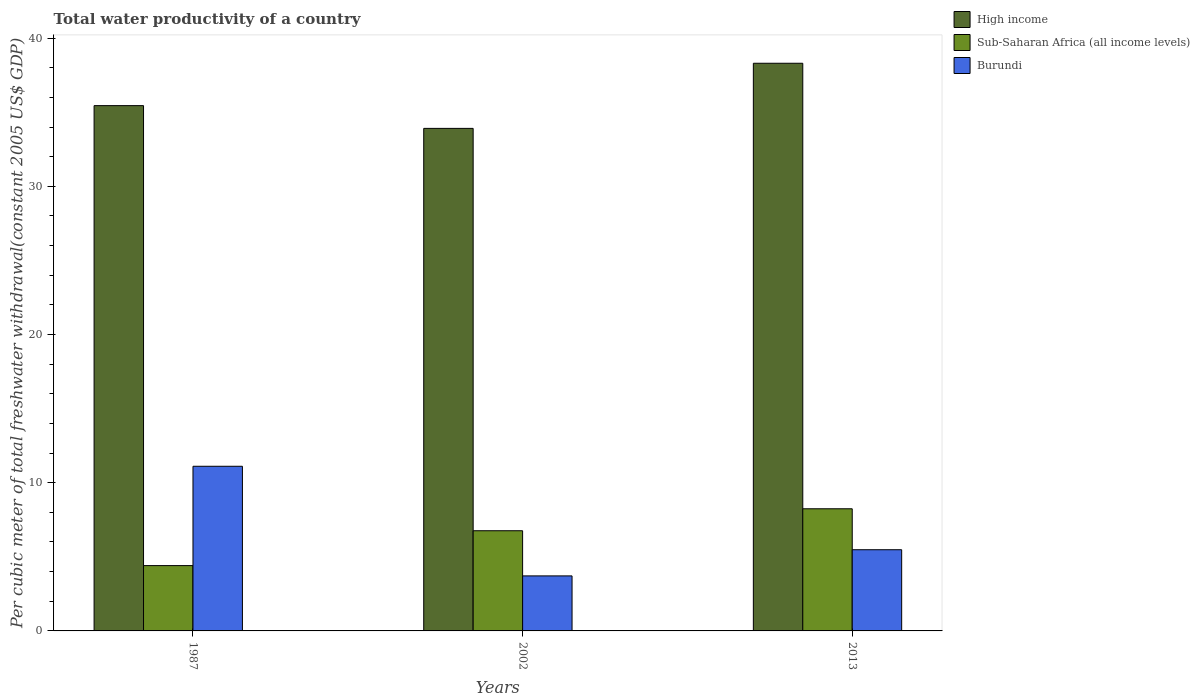How many different coloured bars are there?
Your answer should be very brief. 3. Are the number of bars on each tick of the X-axis equal?
Keep it short and to the point. Yes. How many bars are there on the 1st tick from the right?
Keep it short and to the point. 3. In how many cases, is the number of bars for a given year not equal to the number of legend labels?
Provide a short and direct response. 0. What is the total water productivity in Burundi in 2002?
Offer a very short reply. 3.71. Across all years, what is the maximum total water productivity in High income?
Give a very brief answer. 38.3. Across all years, what is the minimum total water productivity in Burundi?
Provide a succinct answer. 3.71. In which year was the total water productivity in High income maximum?
Make the answer very short. 2013. In which year was the total water productivity in Burundi minimum?
Your response must be concise. 2002. What is the total total water productivity in High income in the graph?
Give a very brief answer. 107.66. What is the difference between the total water productivity in High income in 2002 and that in 2013?
Ensure brevity in your answer.  -4.39. What is the difference between the total water productivity in High income in 2002 and the total water productivity in Burundi in 2013?
Provide a short and direct response. 28.43. What is the average total water productivity in Sub-Saharan Africa (all income levels) per year?
Your answer should be compact. 6.47. In the year 2013, what is the difference between the total water productivity in Burundi and total water productivity in High income?
Ensure brevity in your answer.  -32.82. What is the ratio of the total water productivity in Sub-Saharan Africa (all income levels) in 2002 to that in 2013?
Your answer should be compact. 0.82. Is the difference between the total water productivity in Burundi in 2002 and 2013 greater than the difference between the total water productivity in High income in 2002 and 2013?
Offer a very short reply. Yes. What is the difference between the highest and the second highest total water productivity in Burundi?
Provide a succinct answer. 5.63. What is the difference between the highest and the lowest total water productivity in Burundi?
Keep it short and to the point. 7.4. In how many years, is the total water productivity in Burundi greater than the average total water productivity in Burundi taken over all years?
Ensure brevity in your answer.  1. Is the sum of the total water productivity in Burundi in 1987 and 2002 greater than the maximum total water productivity in High income across all years?
Provide a short and direct response. No. What does the 3rd bar from the left in 2002 represents?
Offer a very short reply. Burundi. What does the 3rd bar from the right in 1987 represents?
Your response must be concise. High income. Is it the case that in every year, the sum of the total water productivity in High income and total water productivity in Sub-Saharan Africa (all income levels) is greater than the total water productivity in Burundi?
Provide a short and direct response. Yes. How many bars are there?
Your response must be concise. 9. What is the difference between two consecutive major ticks on the Y-axis?
Keep it short and to the point. 10. Are the values on the major ticks of Y-axis written in scientific E-notation?
Keep it short and to the point. No. How are the legend labels stacked?
Keep it short and to the point. Vertical. What is the title of the graph?
Offer a terse response. Total water productivity of a country. What is the label or title of the Y-axis?
Offer a terse response. Per cubic meter of total freshwater withdrawal(constant 2005 US$ GDP). What is the Per cubic meter of total freshwater withdrawal(constant 2005 US$ GDP) in High income in 1987?
Give a very brief answer. 35.44. What is the Per cubic meter of total freshwater withdrawal(constant 2005 US$ GDP) of Sub-Saharan Africa (all income levels) in 1987?
Provide a short and direct response. 4.41. What is the Per cubic meter of total freshwater withdrawal(constant 2005 US$ GDP) in Burundi in 1987?
Give a very brief answer. 11.11. What is the Per cubic meter of total freshwater withdrawal(constant 2005 US$ GDP) in High income in 2002?
Ensure brevity in your answer.  33.91. What is the Per cubic meter of total freshwater withdrawal(constant 2005 US$ GDP) in Sub-Saharan Africa (all income levels) in 2002?
Give a very brief answer. 6.76. What is the Per cubic meter of total freshwater withdrawal(constant 2005 US$ GDP) of Burundi in 2002?
Your response must be concise. 3.71. What is the Per cubic meter of total freshwater withdrawal(constant 2005 US$ GDP) of High income in 2013?
Offer a very short reply. 38.3. What is the Per cubic meter of total freshwater withdrawal(constant 2005 US$ GDP) in Sub-Saharan Africa (all income levels) in 2013?
Provide a succinct answer. 8.24. What is the Per cubic meter of total freshwater withdrawal(constant 2005 US$ GDP) of Burundi in 2013?
Provide a short and direct response. 5.48. Across all years, what is the maximum Per cubic meter of total freshwater withdrawal(constant 2005 US$ GDP) in High income?
Provide a succinct answer. 38.3. Across all years, what is the maximum Per cubic meter of total freshwater withdrawal(constant 2005 US$ GDP) of Sub-Saharan Africa (all income levels)?
Offer a very short reply. 8.24. Across all years, what is the maximum Per cubic meter of total freshwater withdrawal(constant 2005 US$ GDP) in Burundi?
Your answer should be compact. 11.11. Across all years, what is the minimum Per cubic meter of total freshwater withdrawal(constant 2005 US$ GDP) in High income?
Provide a succinct answer. 33.91. Across all years, what is the minimum Per cubic meter of total freshwater withdrawal(constant 2005 US$ GDP) of Sub-Saharan Africa (all income levels)?
Ensure brevity in your answer.  4.41. Across all years, what is the minimum Per cubic meter of total freshwater withdrawal(constant 2005 US$ GDP) of Burundi?
Your answer should be compact. 3.71. What is the total Per cubic meter of total freshwater withdrawal(constant 2005 US$ GDP) of High income in the graph?
Your answer should be very brief. 107.66. What is the total Per cubic meter of total freshwater withdrawal(constant 2005 US$ GDP) of Sub-Saharan Africa (all income levels) in the graph?
Offer a terse response. 19.41. What is the total Per cubic meter of total freshwater withdrawal(constant 2005 US$ GDP) in Burundi in the graph?
Offer a very short reply. 20.3. What is the difference between the Per cubic meter of total freshwater withdrawal(constant 2005 US$ GDP) in High income in 1987 and that in 2002?
Keep it short and to the point. 1.53. What is the difference between the Per cubic meter of total freshwater withdrawal(constant 2005 US$ GDP) of Sub-Saharan Africa (all income levels) in 1987 and that in 2002?
Your answer should be very brief. -2.35. What is the difference between the Per cubic meter of total freshwater withdrawal(constant 2005 US$ GDP) of Burundi in 1987 and that in 2002?
Your response must be concise. 7.4. What is the difference between the Per cubic meter of total freshwater withdrawal(constant 2005 US$ GDP) in High income in 1987 and that in 2013?
Provide a succinct answer. -2.86. What is the difference between the Per cubic meter of total freshwater withdrawal(constant 2005 US$ GDP) in Sub-Saharan Africa (all income levels) in 1987 and that in 2013?
Provide a succinct answer. -3.83. What is the difference between the Per cubic meter of total freshwater withdrawal(constant 2005 US$ GDP) in Burundi in 1987 and that in 2013?
Offer a terse response. 5.63. What is the difference between the Per cubic meter of total freshwater withdrawal(constant 2005 US$ GDP) of High income in 2002 and that in 2013?
Your answer should be very brief. -4.39. What is the difference between the Per cubic meter of total freshwater withdrawal(constant 2005 US$ GDP) of Sub-Saharan Africa (all income levels) in 2002 and that in 2013?
Make the answer very short. -1.48. What is the difference between the Per cubic meter of total freshwater withdrawal(constant 2005 US$ GDP) of Burundi in 2002 and that in 2013?
Give a very brief answer. -1.77. What is the difference between the Per cubic meter of total freshwater withdrawal(constant 2005 US$ GDP) in High income in 1987 and the Per cubic meter of total freshwater withdrawal(constant 2005 US$ GDP) in Sub-Saharan Africa (all income levels) in 2002?
Provide a succinct answer. 28.68. What is the difference between the Per cubic meter of total freshwater withdrawal(constant 2005 US$ GDP) in High income in 1987 and the Per cubic meter of total freshwater withdrawal(constant 2005 US$ GDP) in Burundi in 2002?
Make the answer very short. 31.73. What is the difference between the Per cubic meter of total freshwater withdrawal(constant 2005 US$ GDP) of Sub-Saharan Africa (all income levels) in 1987 and the Per cubic meter of total freshwater withdrawal(constant 2005 US$ GDP) of Burundi in 2002?
Give a very brief answer. 0.69. What is the difference between the Per cubic meter of total freshwater withdrawal(constant 2005 US$ GDP) of High income in 1987 and the Per cubic meter of total freshwater withdrawal(constant 2005 US$ GDP) of Sub-Saharan Africa (all income levels) in 2013?
Keep it short and to the point. 27.2. What is the difference between the Per cubic meter of total freshwater withdrawal(constant 2005 US$ GDP) in High income in 1987 and the Per cubic meter of total freshwater withdrawal(constant 2005 US$ GDP) in Burundi in 2013?
Make the answer very short. 29.97. What is the difference between the Per cubic meter of total freshwater withdrawal(constant 2005 US$ GDP) in Sub-Saharan Africa (all income levels) in 1987 and the Per cubic meter of total freshwater withdrawal(constant 2005 US$ GDP) in Burundi in 2013?
Provide a succinct answer. -1.07. What is the difference between the Per cubic meter of total freshwater withdrawal(constant 2005 US$ GDP) of High income in 2002 and the Per cubic meter of total freshwater withdrawal(constant 2005 US$ GDP) of Sub-Saharan Africa (all income levels) in 2013?
Give a very brief answer. 25.67. What is the difference between the Per cubic meter of total freshwater withdrawal(constant 2005 US$ GDP) in High income in 2002 and the Per cubic meter of total freshwater withdrawal(constant 2005 US$ GDP) in Burundi in 2013?
Make the answer very short. 28.43. What is the difference between the Per cubic meter of total freshwater withdrawal(constant 2005 US$ GDP) of Sub-Saharan Africa (all income levels) in 2002 and the Per cubic meter of total freshwater withdrawal(constant 2005 US$ GDP) of Burundi in 2013?
Provide a succinct answer. 1.28. What is the average Per cubic meter of total freshwater withdrawal(constant 2005 US$ GDP) of High income per year?
Give a very brief answer. 35.89. What is the average Per cubic meter of total freshwater withdrawal(constant 2005 US$ GDP) of Sub-Saharan Africa (all income levels) per year?
Provide a short and direct response. 6.47. What is the average Per cubic meter of total freshwater withdrawal(constant 2005 US$ GDP) in Burundi per year?
Offer a very short reply. 6.77. In the year 1987, what is the difference between the Per cubic meter of total freshwater withdrawal(constant 2005 US$ GDP) in High income and Per cubic meter of total freshwater withdrawal(constant 2005 US$ GDP) in Sub-Saharan Africa (all income levels)?
Your answer should be very brief. 31.04. In the year 1987, what is the difference between the Per cubic meter of total freshwater withdrawal(constant 2005 US$ GDP) of High income and Per cubic meter of total freshwater withdrawal(constant 2005 US$ GDP) of Burundi?
Provide a short and direct response. 24.33. In the year 1987, what is the difference between the Per cubic meter of total freshwater withdrawal(constant 2005 US$ GDP) in Sub-Saharan Africa (all income levels) and Per cubic meter of total freshwater withdrawal(constant 2005 US$ GDP) in Burundi?
Offer a very short reply. -6.7. In the year 2002, what is the difference between the Per cubic meter of total freshwater withdrawal(constant 2005 US$ GDP) of High income and Per cubic meter of total freshwater withdrawal(constant 2005 US$ GDP) of Sub-Saharan Africa (all income levels)?
Ensure brevity in your answer.  27.15. In the year 2002, what is the difference between the Per cubic meter of total freshwater withdrawal(constant 2005 US$ GDP) in High income and Per cubic meter of total freshwater withdrawal(constant 2005 US$ GDP) in Burundi?
Make the answer very short. 30.2. In the year 2002, what is the difference between the Per cubic meter of total freshwater withdrawal(constant 2005 US$ GDP) in Sub-Saharan Africa (all income levels) and Per cubic meter of total freshwater withdrawal(constant 2005 US$ GDP) in Burundi?
Offer a very short reply. 3.05. In the year 2013, what is the difference between the Per cubic meter of total freshwater withdrawal(constant 2005 US$ GDP) of High income and Per cubic meter of total freshwater withdrawal(constant 2005 US$ GDP) of Sub-Saharan Africa (all income levels)?
Your answer should be compact. 30.06. In the year 2013, what is the difference between the Per cubic meter of total freshwater withdrawal(constant 2005 US$ GDP) of High income and Per cubic meter of total freshwater withdrawal(constant 2005 US$ GDP) of Burundi?
Provide a short and direct response. 32.82. In the year 2013, what is the difference between the Per cubic meter of total freshwater withdrawal(constant 2005 US$ GDP) of Sub-Saharan Africa (all income levels) and Per cubic meter of total freshwater withdrawal(constant 2005 US$ GDP) of Burundi?
Your answer should be very brief. 2.76. What is the ratio of the Per cubic meter of total freshwater withdrawal(constant 2005 US$ GDP) in High income in 1987 to that in 2002?
Provide a short and direct response. 1.05. What is the ratio of the Per cubic meter of total freshwater withdrawal(constant 2005 US$ GDP) in Sub-Saharan Africa (all income levels) in 1987 to that in 2002?
Provide a short and direct response. 0.65. What is the ratio of the Per cubic meter of total freshwater withdrawal(constant 2005 US$ GDP) in Burundi in 1987 to that in 2002?
Offer a very short reply. 2.99. What is the ratio of the Per cubic meter of total freshwater withdrawal(constant 2005 US$ GDP) of High income in 1987 to that in 2013?
Provide a succinct answer. 0.93. What is the ratio of the Per cubic meter of total freshwater withdrawal(constant 2005 US$ GDP) of Sub-Saharan Africa (all income levels) in 1987 to that in 2013?
Ensure brevity in your answer.  0.53. What is the ratio of the Per cubic meter of total freshwater withdrawal(constant 2005 US$ GDP) in Burundi in 1987 to that in 2013?
Offer a terse response. 2.03. What is the ratio of the Per cubic meter of total freshwater withdrawal(constant 2005 US$ GDP) of High income in 2002 to that in 2013?
Provide a short and direct response. 0.89. What is the ratio of the Per cubic meter of total freshwater withdrawal(constant 2005 US$ GDP) in Sub-Saharan Africa (all income levels) in 2002 to that in 2013?
Your answer should be very brief. 0.82. What is the ratio of the Per cubic meter of total freshwater withdrawal(constant 2005 US$ GDP) in Burundi in 2002 to that in 2013?
Provide a short and direct response. 0.68. What is the difference between the highest and the second highest Per cubic meter of total freshwater withdrawal(constant 2005 US$ GDP) of High income?
Make the answer very short. 2.86. What is the difference between the highest and the second highest Per cubic meter of total freshwater withdrawal(constant 2005 US$ GDP) in Sub-Saharan Africa (all income levels)?
Make the answer very short. 1.48. What is the difference between the highest and the second highest Per cubic meter of total freshwater withdrawal(constant 2005 US$ GDP) of Burundi?
Your response must be concise. 5.63. What is the difference between the highest and the lowest Per cubic meter of total freshwater withdrawal(constant 2005 US$ GDP) in High income?
Your answer should be very brief. 4.39. What is the difference between the highest and the lowest Per cubic meter of total freshwater withdrawal(constant 2005 US$ GDP) in Sub-Saharan Africa (all income levels)?
Offer a very short reply. 3.83. What is the difference between the highest and the lowest Per cubic meter of total freshwater withdrawal(constant 2005 US$ GDP) in Burundi?
Ensure brevity in your answer.  7.4. 